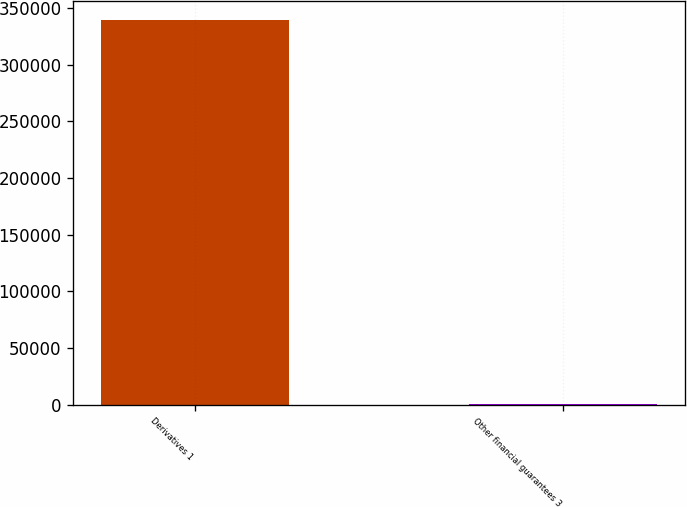Convert chart. <chart><loc_0><loc_0><loc_500><loc_500><bar_chart><fcel>Derivatives 1<fcel>Other financial guarantees 3<nl><fcel>339460<fcel>904<nl></chart> 